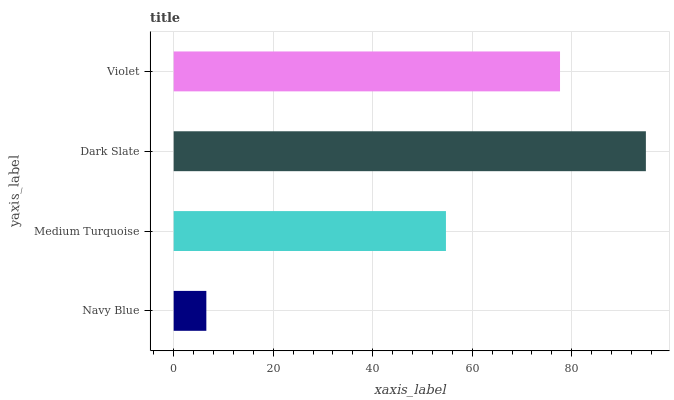Is Navy Blue the minimum?
Answer yes or no. Yes. Is Dark Slate the maximum?
Answer yes or no. Yes. Is Medium Turquoise the minimum?
Answer yes or no. No. Is Medium Turquoise the maximum?
Answer yes or no. No. Is Medium Turquoise greater than Navy Blue?
Answer yes or no. Yes. Is Navy Blue less than Medium Turquoise?
Answer yes or no. Yes. Is Navy Blue greater than Medium Turquoise?
Answer yes or no. No. Is Medium Turquoise less than Navy Blue?
Answer yes or no. No. Is Violet the high median?
Answer yes or no. Yes. Is Medium Turquoise the low median?
Answer yes or no. Yes. Is Dark Slate the high median?
Answer yes or no. No. Is Dark Slate the low median?
Answer yes or no. No. 